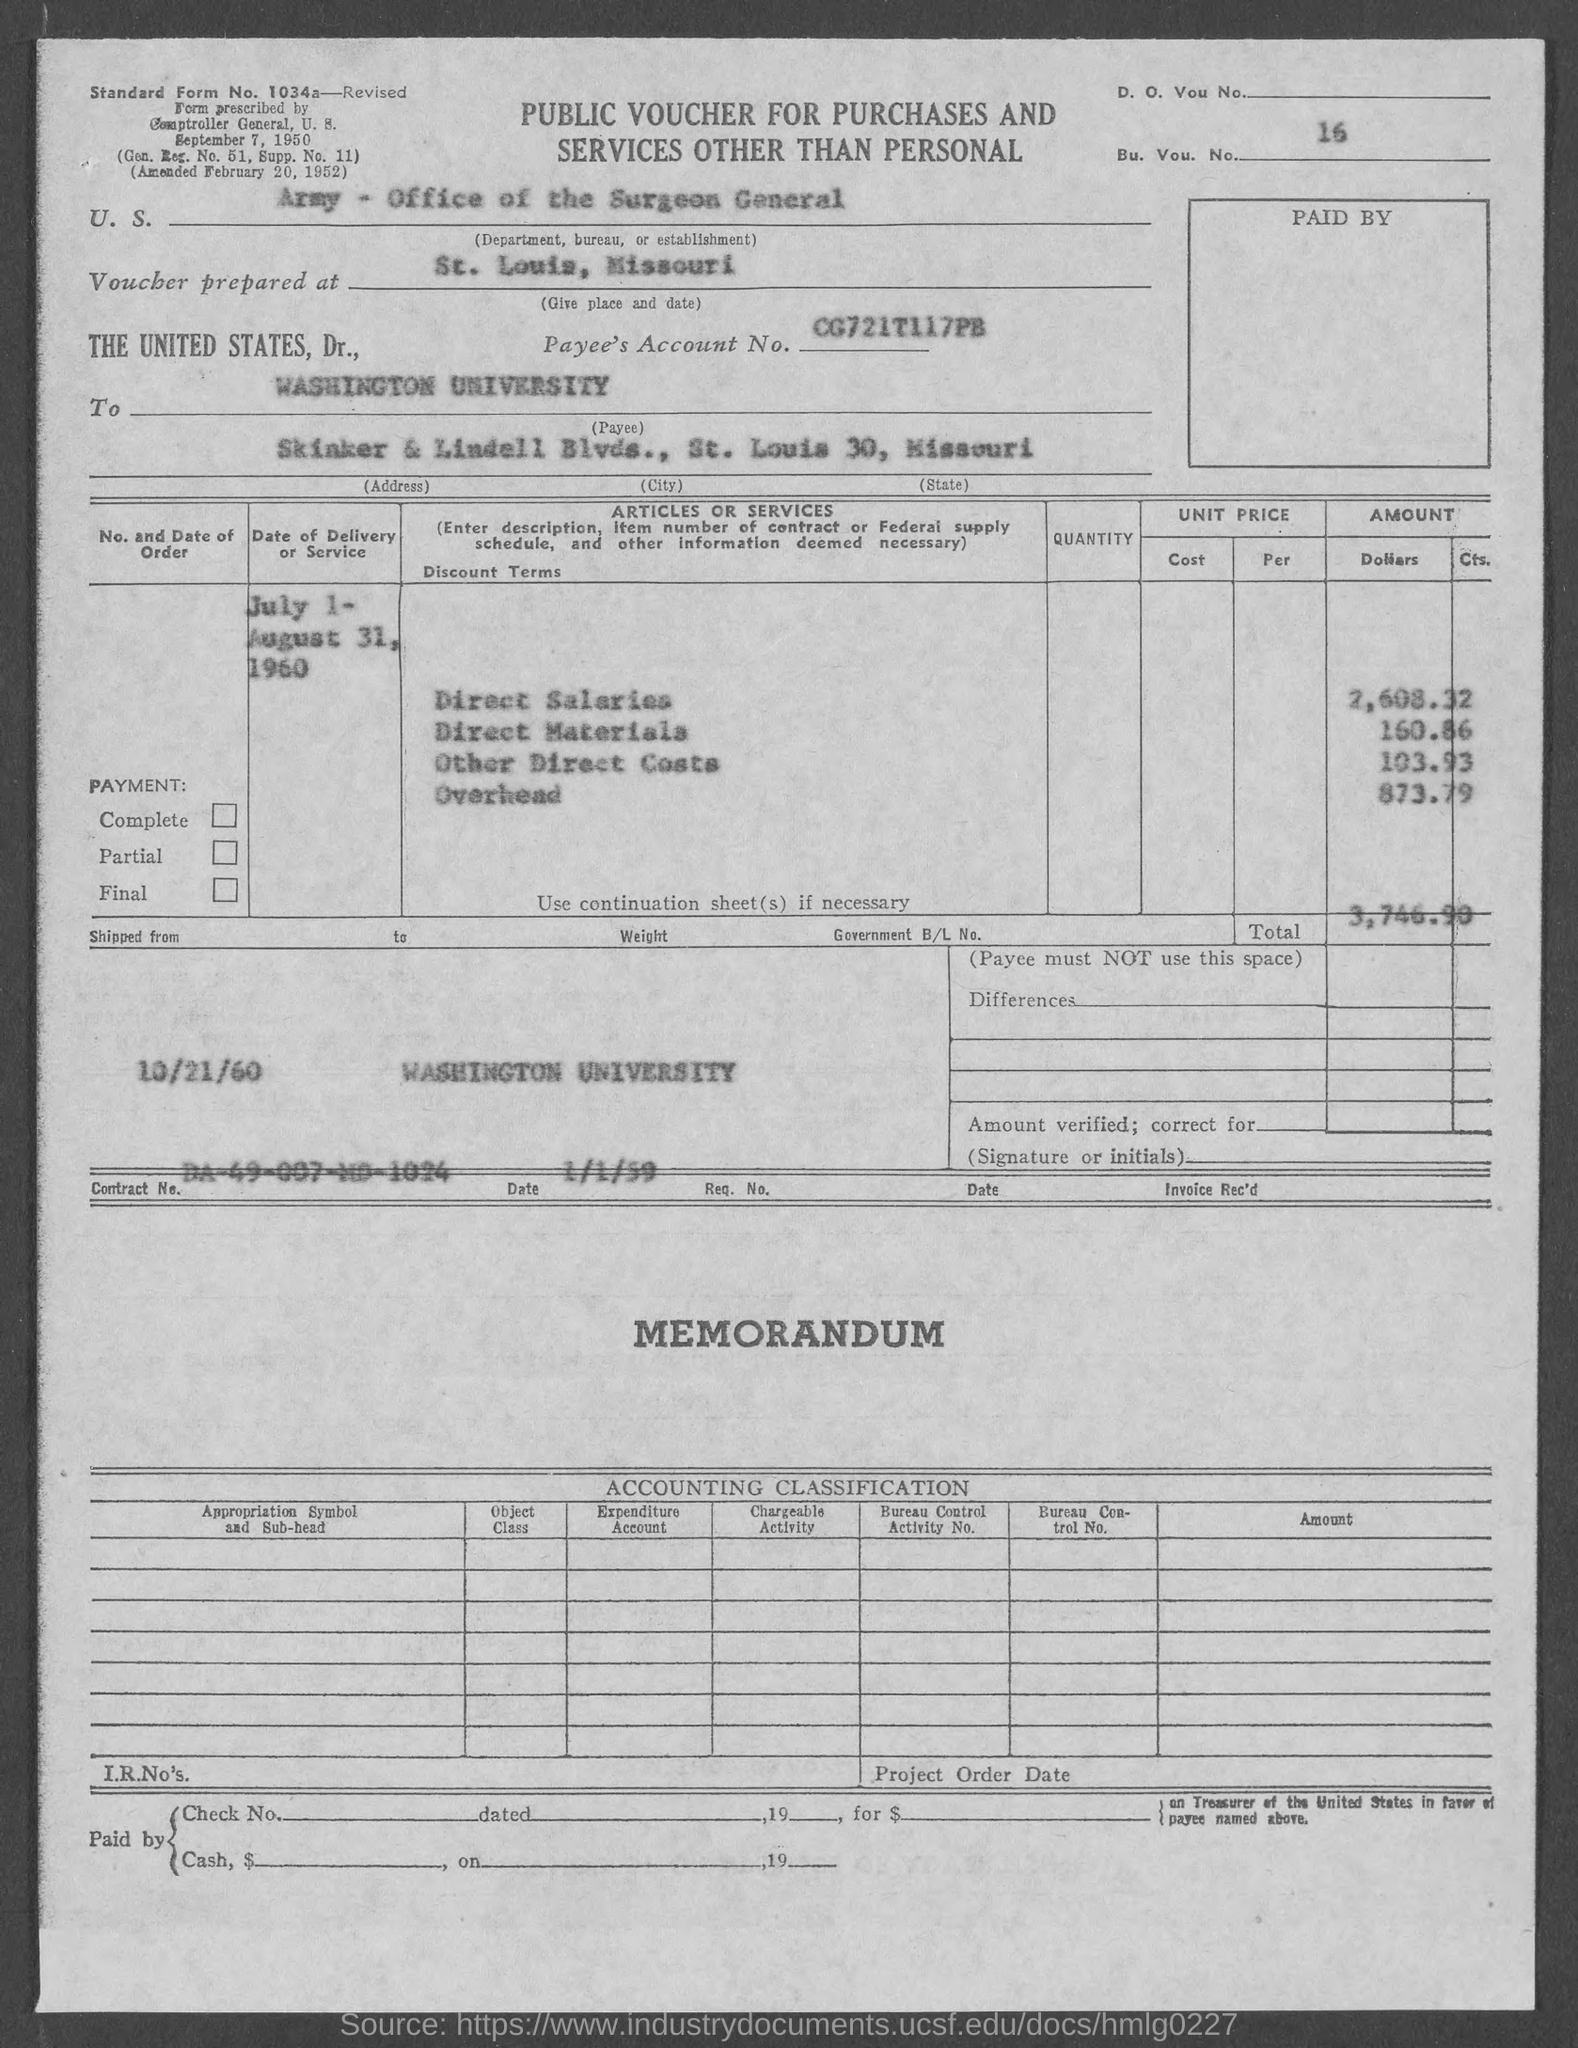Draw attention to some important aspects in this diagram. The total cost is 3,746.90. The value of overhead is 873.79. The value of direct salaries is 2,608.32. Other Direct Costs" is valued at $103.93. The value of direct materials is 160.86. 